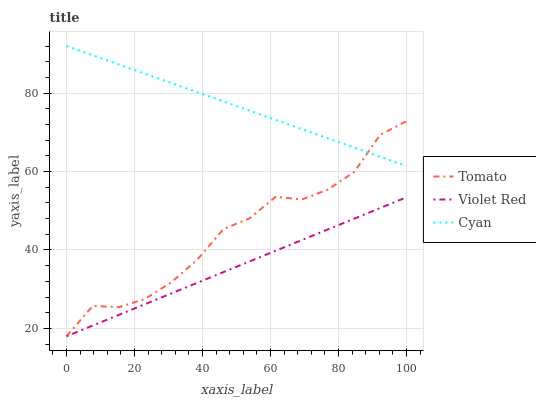Does Cyan have the minimum area under the curve?
Answer yes or no. No. Does Violet Red have the maximum area under the curve?
Answer yes or no. No. Is Cyan the smoothest?
Answer yes or no. No. Is Cyan the roughest?
Answer yes or no. No. Does Cyan have the lowest value?
Answer yes or no. No. Does Violet Red have the highest value?
Answer yes or no. No. Is Violet Red less than Cyan?
Answer yes or no. Yes. Is Cyan greater than Violet Red?
Answer yes or no. Yes. Does Violet Red intersect Cyan?
Answer yes or no. No. 